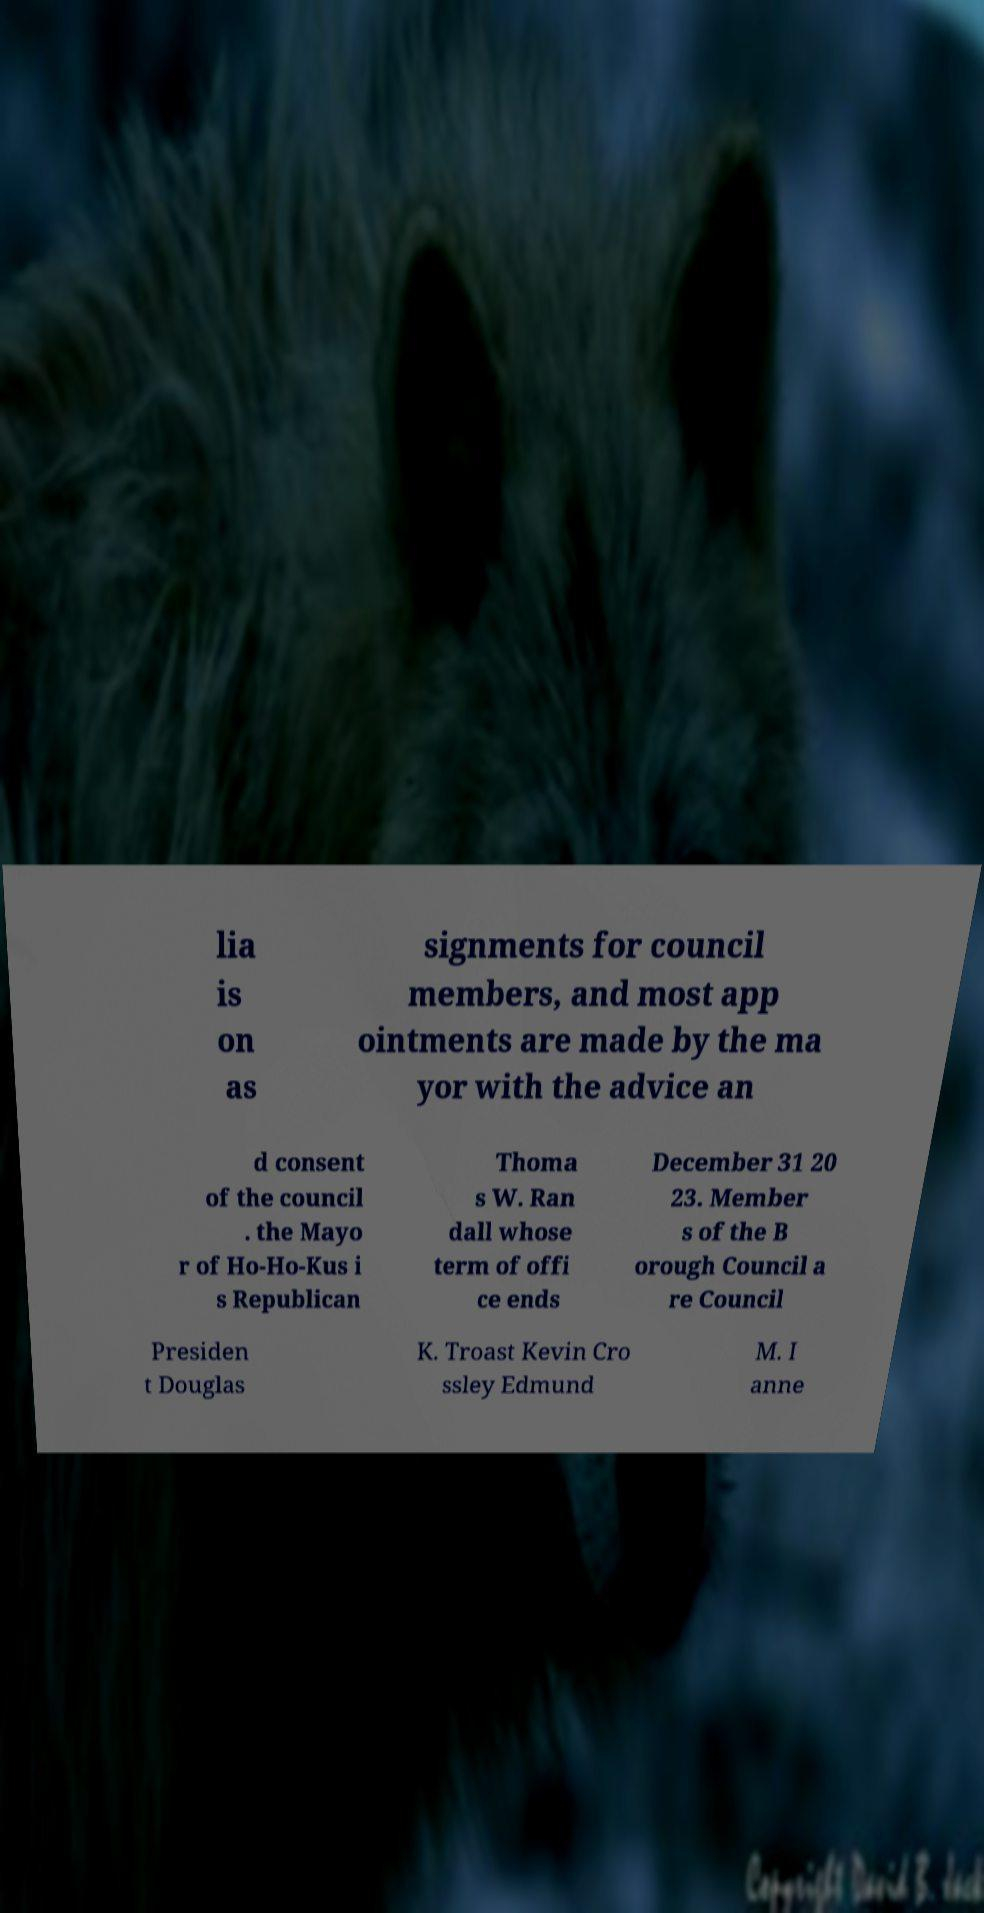Please read and relay the text visible in this image. What does it say? lia is on as signments for council members, and most app ointments are made by the ma yor with the advice an d consent of the council . the Mayo r of Ho-Ho-Kus i s Republican Thoma s W. Ran dall whose term of offi ce ends December 31 20 23. Member s of the B orough Council a re Council Presiden t Douglas K. Troast Kevin Cro ssley Edmund M. I anne 